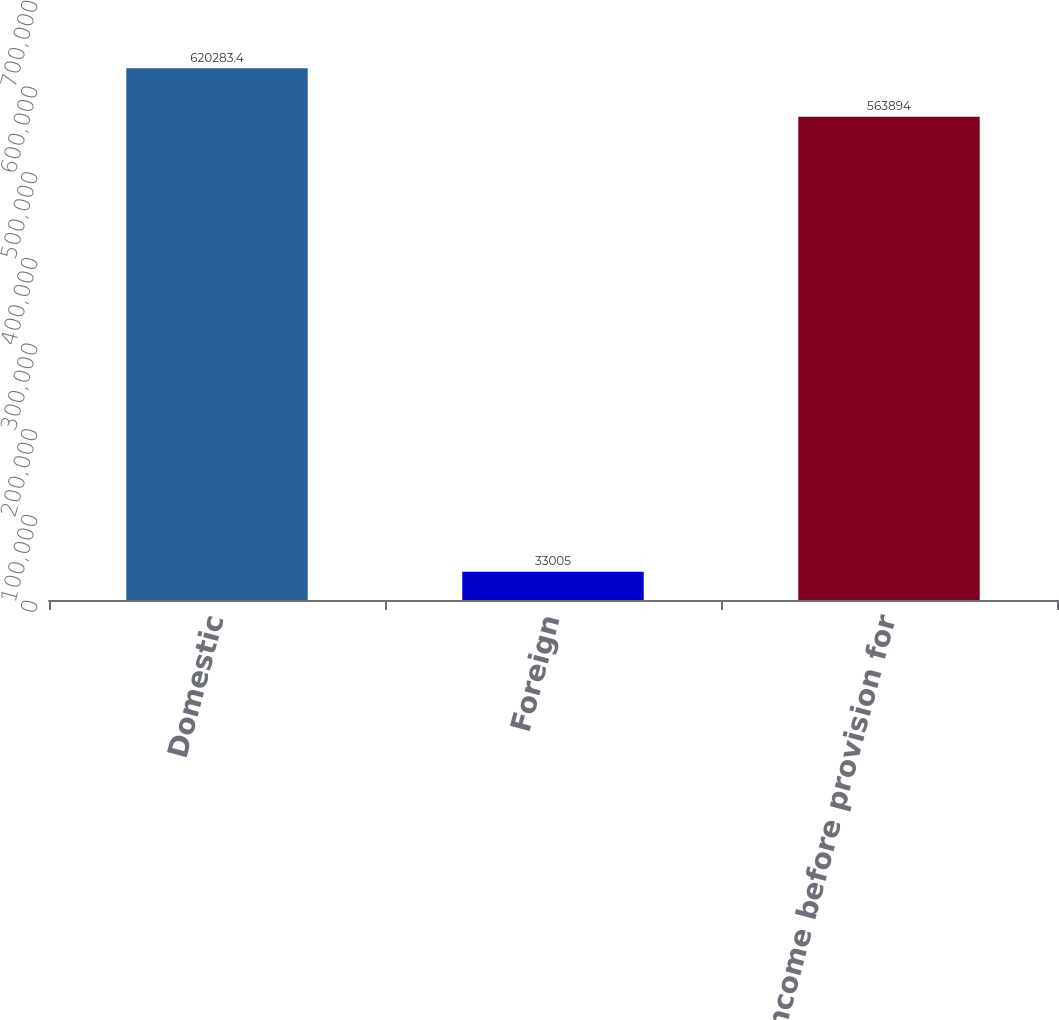<chart> <loc_0><loc_0><loc_500><loc_500><bar_chart><fcel>Domestic<fcel>Foreign<fcel>Income before provision for<nl><fcel>620283<fcel>33005<fcel>563894<nl></chart> 